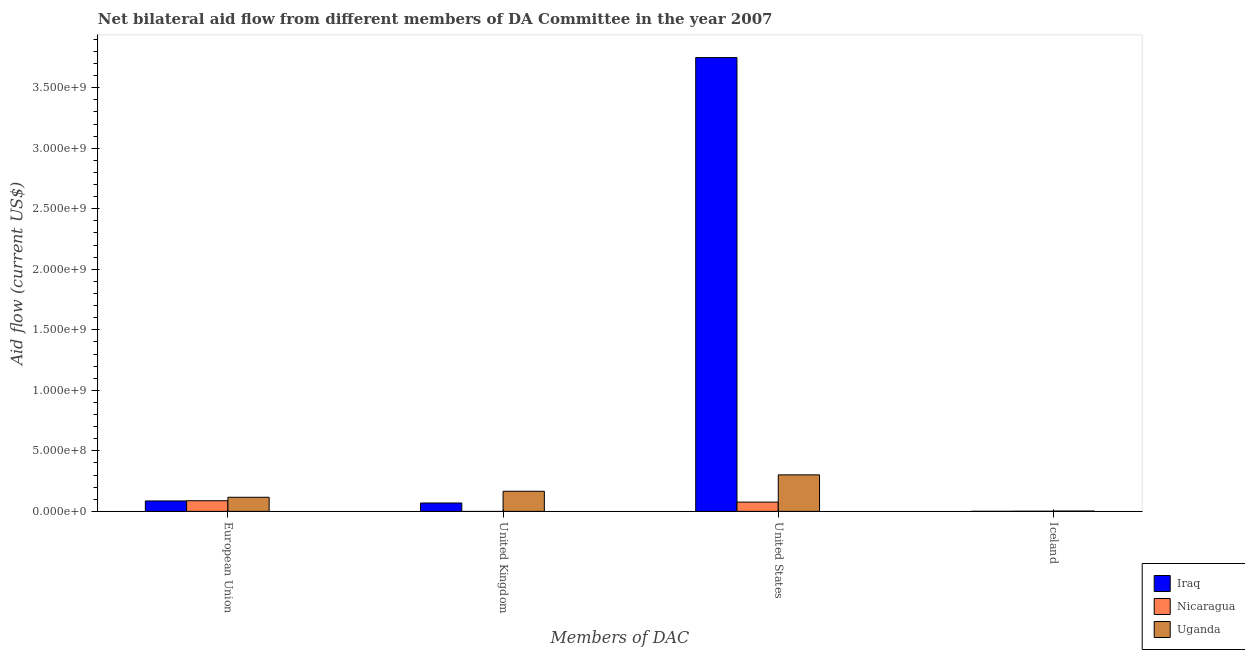Are the number of bars on each tick of the X-axis equal?
Ensure brevity in your answer.  No. How many bars are there on the 1st tick from the right?
Make the answer very short. 3. What is the label of the 4th group of bars from the left?
Keep it short and to the point. Iceland. What is the amount of aid given by eu in Nicaragua?
Make the answer very short. 8.78e+07. Across all countries, what is the maximum amount of aid given by uk?
Your response must be concise. 1.66e+08. Across all countries, what is the minimum amount of aid given by eu?
Your response must be concise. 8.61e+07. In which country was the amount of aid given by iceland maximum?
Provide a succinct answer. Uganda. What is the total amount of aid given by eu in the graph?
Provide a succinct answer. 2.90e+08. What is the difference between the amount of aid given by eu in Iraq and that in Uganda?
Your answer should be compact. -3.03e+07. What is the difference between the amount of aid given by uk in Nicaragua and the amount of aid given by us in Iraq?
Keep it short and to the point. -3.75e+09. What is the average amount of aid given by uk per country?
Your answer should be compact. 7.84e+07. What is the difference between the amount of aid given by uk and amount of aid given by us in Iraq?
Offer a terse response. -3.68e+09. What is the ratio of the amount of aid given by eu in Uganda to that in Nicaragua?
Ensure brevity in your answer.  1.32. Is the amount of aid given by iceland in Nicaragua less than that in Uganda?
Your response must be concise. Yes. What is the difference between the highest and the second highest amount of aid given by iceland?
Provide a succinct answer. 1.51e+06. What is the difference between the highest and the lowest amount of aid given by eu?
Offer a terse response. 3.03e+07. Is the sum of the amount of aid given by us in Iraq and Uganda greater than the maximum amount of aid given by iceland across all countries?
Your answer should be compact. Yes. Is it the case that in every country, the sum of the amount of aid given by eu and amount of aid given by uk is greater than the amount of aid given by us?
Your answer should be compact. No. Are all the bars in the graph horizontal?
Make the answer very short. No. How many countries are there in the graph?
Your answer should be compact. 3. What is the difference between two consecutive major ticks on the Y-axis?
Keep it short and to the point. 5.00e+08. Are the values on the major ticks of Y-axis written in scientific E-notation?
Your answer should be very brief. Yes. Does the graph contain any zero values?
Give a very brief answer. Yes. Where does the legend appear in the graph?
Offer a very short reply. Bottom right. How are the legend labels stacked?
Make the answer very short. Vertical. What is the title of the graph?
Your response must be concise. Net bilateral aid flow from different members of DA Committee in the year 2007. What is the label or title of the X-axis?
Your answer should be compact. Members of DAC. What is the label or title of the Y-axis?
Give a very brief answer. Aid flow (current US$). What is the Aid flow (current US$) in Iraq in European Union?
Make the answer very short. 8.61e+07. What is the Aid flow (current US$) of Nicaragua in European Union?
Your answer should be compact. 8.78e+07. What is the Aid flow (current US$) of Uganda in European Union?
Provide a succinct answer. 1.16e+08. What is the Aid flow (current US$) of Iraq in United Kingdom?
Your answer should be compact. 6.92e+07. What is the Aid flow (current US$) of Nicaragua in United Kingdom?
Keep it short and to the point. 0. What is the Aid flow (current US$) of Uganda in United Kingdom?
Offer a very short reply. 1.66e+08. What is the Aid flow (current US$) in Iraq in United States?
Provide a succinct answer. 3.75e+09. What is the Aid flow (current US$) in Nicaragua in United States?
Provide a succinct answer. 7.65e+07. What is the Aid flow (current US$) in Uganda in United States?
Offer a very short reply. 3.02e+08. What is the Aid flow (current US$) in Iraq in Iceland?
Your answer should be very brief. 2.90e+05. What is the Aid flow (current US$) of Nicaragua in Iceland?
Provide a short and direct response. 1.05e+06. What is the Aid flow (current US$) in Uganda in Iceland?
Offer a very short reply. 2.56e+06. Across all Members of DAC, what is the maximum Aid flow (current US$) of Iraq?
Offer a very short reply. 3.75e+09. Across all Members of DAC, what is the maximum Aid flow (current US$) in Nicaragua?
Offer a terse response. 8.78e+07. Across all Members of DAC, what is the maximum Aid flow (current US$) in Uganda?
Your response must be concise. 3.02e+08. Across all Members of DAC, what is the minimum Aid flow (current US$) in Iraq?
Offer a very short reply. 2.90e+05. Across all Members of DAC, what is the minimum Aid flow (current US$) in Uganda?
Keep it short and to the point. 2.56e+06. What is the total Aid flow (current US$) in Iraq in the graph?
Provide a short and direct response. 3.90e+09. What is the total Aid flow (current US$) of Nicaragua in the graph?
Make the answer very short. 1.65e+08. What is the total Aid flow (current US$) in Uganda in the graph?
Keep it short and to the point. 5.87e+08. What is the difference between the Aid flow (current US$) of Iraq in European Union and that in United Kingdom?
Give a very brief answer. 1.69e+07. What is the difference between the Aid flow (current US$) in Uganda in European Union and that in United Kingdom?
Make the answer very short. -4.98e+07. What is the difference between the Aid flow (current US$) in Iraq in European Union and that in United States?
Offer a very short reply. -3.66e+09. What is the difference between the Aid flow (current US$) of Nicaragua in European Union and that in United States?
Offer a terse response. 1.13e+07. What is the difference between the Aid flow (current US$) in Uganda in European Union and that in United States?
Make the answer very short. -1.85e+08. What is the difference between the Aid flow (current US$) of Iraq in European Union and that in Iceland?
Your answer should be compact. 8.58e+07. What is the difference between the Aid flow (current US$) of Nicaragua in European Union and that in Iceland?
Offer a very short reply. 8.68e+07. What is the difference between the Aid flow (current US$) in Uganda in European Union and that in Iceland?
Offer a terse response. 1.14e+08. What is the difference between the Aid flow (current US$) in Iraq in United Kingdom and that in United States?
Your answer should be very brief. -3.68e+09. What is the difference between the Aid flow (current US$) in Uganda in United Kingdom and that in United States?
Provide a succinct answer. -1.35e+08. What is the difference between the Aid flow (current US$) in Iraq in United Kingdom and that in Iceland?
Your answer should be compact. 6.89e+07. What is the difference between the Aid flow (current US$) in Uganda in United Kingdom and that in Iceland?
Make the answer very short. 1.64e+08. What is the difference between the Aid flow (current US$) of Iraq in United States and that in Iceland?
Keep it short and to the point. 3.75e+09. What is the difference between the Aid flow (current US$) in Nicaragua in United States and that in Iceland?
Offer a terse response. 7.55e+07. What is the difference between the Aid flow (current US$) of Uganda in United States and that in Iceland?
Provide a succinct answer. 2.99e+08. What is the difference between the Aid flow (current US$) of Iraq in European Union and the Aid flow (current US$) of Uganda in United Kingdom?
Your answer should be very brief. -8.01e+07. What is the difference between the Aid flow (current US$) of Nicaragua in European Union and the Aid flow (current US$) of Uganda in United Kingdom?
Provide a short and direct response. -7.83e+07. What is the difference between the Aid flow (current US$) in Iraq in European Union and the Aid flow (current US$) in Nicaragua in United States?
Offer a very short reply. 9.54e+06. What is the difference between the Aid flow (current US$) of Iraq in European Union and the Aid flow (current US$) of Uganda in United States?
Make the answer very short. -2.16e+08. What is the difference between the Aid flow (current US$) in Nicaragua in European Union and the Aid flow (current US$) in Uganda in United States?
Make the answer very short. -2.14e+08. What is the difference between the Aid flow (current US$) of Iraq in European Union and the Aid flow (current US$) of Nicaragua in Iceland?
Give a very brief answer. 8.50e+07. What is the difference between the Aid flow (current US$) of Iraq in European Union and the Aid flow (current US$) of Uganda in Iceland?
Offer a very short reply. 8.35e+07. What is the difference between the Aid flow (current US$) in Nicaragua in European Union and the Aid flow (current US$) in Uganda in Iceland?
Ensure brevity in your answer.  8.53e+07. What is the difference between the Aid flow (current US$) of Iraq in United Kingdom and the Aid flow (current US$) of Nicaragua in United States?
Give a very brief answer. -7.36e+06. What is the difference between the Aid flow (current US$) in Iraq in United Kingdom and the Aid flow (current US$) in Uganda in United States?
Ensure brevity in your answer.  -2.32e+08. What is the difference between the Aid flow (current US$) of Iraq in United Kingdom and the Aid flow (current US$) of Nicaragua in Iceland?
Give a very brief answer. 6.81e+07. What is the difference between the Aid flow (current US$) in Iraq in United Kingdom and the Aid flow (current US$) in Uganda in Iceland?
Ensure brevity in your answer.  6.66e+07. What is the difference between the Aid flow (current US$) of Iraq in United States and the Aid flow (current US$) of Nicaragua in Iceland?
Make the answer very short. 3.75e+09. What is the difference between the Aid flow (current US$) in Iraq in United States and the Aid flow (current US$) in Uganda in Iceland?
Provide a short and direct response. 3.75e+09. What is the difference between the Aid flow (current US$) of Nicaragua in United States and the Aid flow (current US$) of Uganda in Iceland?
Provide a succinct answer. 7.40e+07. What is the average Aid flow (current US$) in Iraq per Members of DAC?
Keep it short and to the point. 9.76e+08. What is the average Aid flow (current US$) in Nicaragua per Members of DAC?
Give a very brief answer. 4.14e+07. What is the average Aid flow (current US$) of Uganda per Members of DAC?
Provide a short and direct response. 1.47e+08. What is the difference between the Aid flow (current US$) of Iraq and Aid flow (current US$) of Nicaragua in European Union?
Provide a short and direct response. -1.77e+06. What is the difference between the Aid flow (current US$) in Iraq and Aid flow (current US$) in Uganda in European Union?
Keep it short and to the point. -3.03e+07. What is the difference between the Aid flow (current US$) in Nicaragua and Aid flow (current US$) in Uganda in European Union?
Your answer should be compact. -2.85e+07. What is the difference between the Aid flow (current US$) of Iraq and Aid flow (current US$) of Uganda in United Kingdom?
Your answer should be compact. -9.70e+07. What is the difference between the Aid flow (current US$) in Iraq and Aid flow (current US$) in Nicaragua in United States?
Keep it short and to the point. 3.67e+09. What is the difference between the Aid flow (current US$) in Iraq and Aid flow (current US$) in Uganda in United States?
Ensure brevity in your answer.  3.45e+09. What is the difference between the Aid flow (current US$) of Nicaragua and Aid flow (current US$) of Uganda in United States?
Provide a short and direct response. -2.25e+08. What is the difference between the Aid flow (current US$) in Iraq and Aid flow (current US$) in Nicaragua in Iceland?
Keep it short and to the point. -7.60e+05. What is the difference between the Aid flow (current US$) of Iraq and Aid flow (current US$) of Uganda in Iceland?
Offer a very short reply. -2.27e+06. What is the difference between the Aid flow (current US$) of Nicaragua and Aid flow (current US$) of Uganda in Iceland?
Make the answer very short. -1.51e+06. What is the ratio of the Aid flow (current US$) in Iraq in European Union to that in United Kingdom?
Your answer should be very brief. 1.24. What is the ratio of the Aid flow (current US$) of Uganda in European Union to that in United Kingdom?
Give a very brief answer. 0.7. What is the ratio of the Aid flow (current US$) of Iraq in European Union to that in United States?
Your response must be concise. 0.02. What is the ratio of the Aid flow (current US$) in Nicaragua in European Union to that in United States?
Make the answer very short. 1.15. What is the ratio of the Aid flow (current US$) of Uganda in European Union to that in United States?
Offer a very short reply. 0.39. What is the ratio of the Aid flow (current US$) of Iraq in European Union to that in Iceland?
Your answer should be compact. 296.79. What is the ratio of the Aid flow (current US$) in Nicaragua in European Union to that in Iceland?
Make the answer very short. 83.66. What is the ratio of the Aid flow (current US$) of Uganda in European Union to that in Iceland?
Keep it short and to the point. 45.45. What is the ratio of the Aid flow (current US$) of Iraq in United Kingdom to that in United States?
Ensure brevity in your answer.  0.02. What is the ratio of the Aid flow (current US$) of Uganda in United Kingdom to that in United States?
Keep it short and to the point. 0.55. What is the ratio of the Aid flow (current US$) of Iraq in United Kingdom to that in Iceland?
Your answer should be very brief. 238.52. What is the ratio of the Aid flow (current US$) of Uganda in United Kingdom to that in Iceland?
Make the answer very short. 64.89. What is the ratio of the Aid flow (current US$) in Iraq in United States to that in Iceland?
Provide a succinct answer. 1.29e+04. What is the ratio of the Aid flow (current US$) in Nicaragua in United States to that in Iceland?
Your answer should be very brief. 72.89. What is the ratio of the Aid flow (current US$) of Uganda in United States to that in Iceland?
Provide a succinct answer. 117.8. What is the difference between the highest and the second highest Aid flow (current US$) of Iraq?
Provide a succinct answer. 3.66e+09. What is the difference between the highest and the second highest Aid flow (current US$) in Nicaragua?
Give a very brief answer. 1.13e+07. What is the difference between the highest and the second highest Aid flow (current US$) of Uganda?
Give a very brief answer. 1.35e+08. What is the difference between the highest and the lowest Aid flow (current US$) in Iraq?
Your answer should be very brief. 3.75e+09. What is the difference between the highest and the lowest Aid flow (current US$) in Nicaragua?
Your answer should be very brief. 8.78e+07. What is the difference between the highest and the lowest Aid flow (current US$) in Uganda?
Keep it short and to the point. 2.99e+08. 